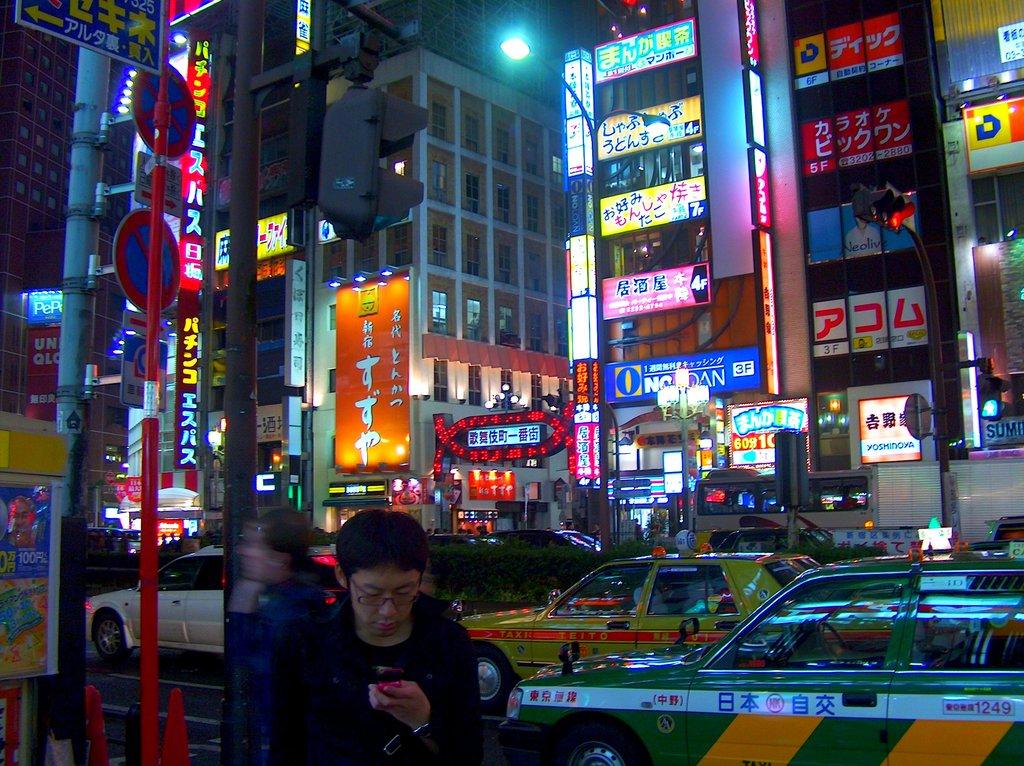What number and letter is shown on the blue sign?
Provide a succinct answer. 3f. 